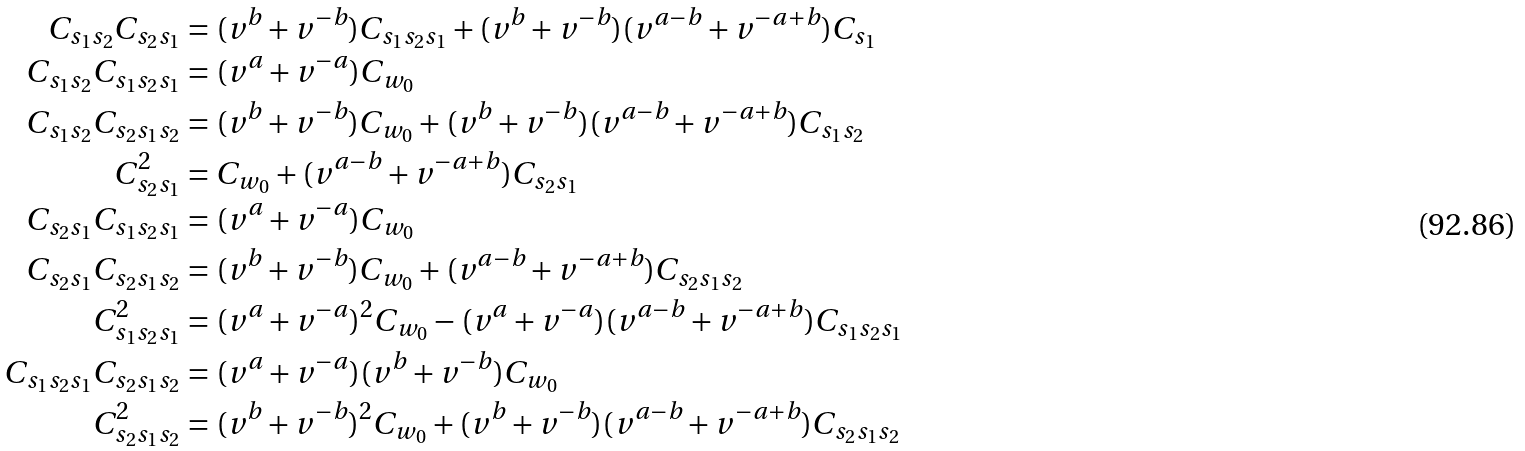<formula> <loc_0><loc_0><loc_500><loc_500>C _ { s _ { 1 } s _ { 2 } } C _ { s _ { 2 } s _ { 1 } } & = ( v ^ { b } + v ^ { - b } ) C _ { s _ { 1 } s _ { 2 } s _ { 1 } } + ( v ^ { b } + v ^ { - b } ) ( v ^ { a - b } + v ^ { - a + b } ) C _ { s _ { 1 } } \\ C _ { s _ { 1 } s _ { 2 } } C _ { s _ { 1 } s _ { 2 } s _ { 1 } } & = ( v ^ { a } + v ^ { - a } ) C _ { w _ { 0 } } \\ C _ { s _ { 1 } s _ { 2 } } C _ { s _ { 2 } s _ { 1 } s _ { 2 } } & = ( v ^ { b } + v ^ { - b } ) C _ { w _ { 0 } } + ( v ^ { b } + v ^ { - b } ) ( v ^ { a - b } + v ^ { - a + b } ) C _ { s _ { 1 } s _ { 2 } } \\ C _ { s _ { 2 } s _ { 1 } } ^ { 2 } & = C _ { w _ { 0 } } + ( v ^ { a - b } + v ^ { - a + b } ) C _ { s _ { 2 } s _ { 1 } } \\ C _ { s _ { 2 } s _ { 1 } } C _ { s _ { 1 } s _ { 2 } s _ { 1 } } & = ( v ^ { a } + v ^ { - a } ) C _ { w _ { 0 } } \\ C _ { s _ { 2 } s _ { 1 } } C _ { s _ { 2 } s _ { 1 } s _ { 2 } } & = ( v ^ { b } + v ^ { - b } ) C _ { w _ { 0 } } + ( v ^ { a - b } + v ^ { - a + b } ) C _ { s _ { 2 } s _ { 1 } s _ { 2 } } \\ C _ { s _ { 1 } s _ { 2 } s _ { 1 } } ^ { 2 } & = ( v ^ { a } + v ^ { - a } ) ^ { 2 } C _ { w _ { 0 } } - ( v ^ { a } + v ^ { - a } ) ( v ^ { a - b } + v ^ { - a + b } ) C _ { s _ { 1 } s _ { 2 } s _ { 1 } } \\ C _ { s _ { 1 } s _ { 2 } s _ { 1 } } C _ { s _ { 2 } s _ { 1 } s _ { 2 } } & = ( v ^ { a } + v ^ { - a } ) ( v ^ { b } + v ^ { - b } ) C _ { w _ { 0 } } \\ C _ { s _ { 2 } s _ { 1 } s _ { 2 } } ^ { 2 } & = ( v ^ { b } + v ^ { - b } ) ^ { 2 } C _ { w _ { 0 } } + ( v ^ { b } + v ^ { - b } ) ( v ^ { a - b } + v ^ { - a + b } ) C _ { s _ { 2 } s _ { 1 } s _ { 2 } }</formula> 